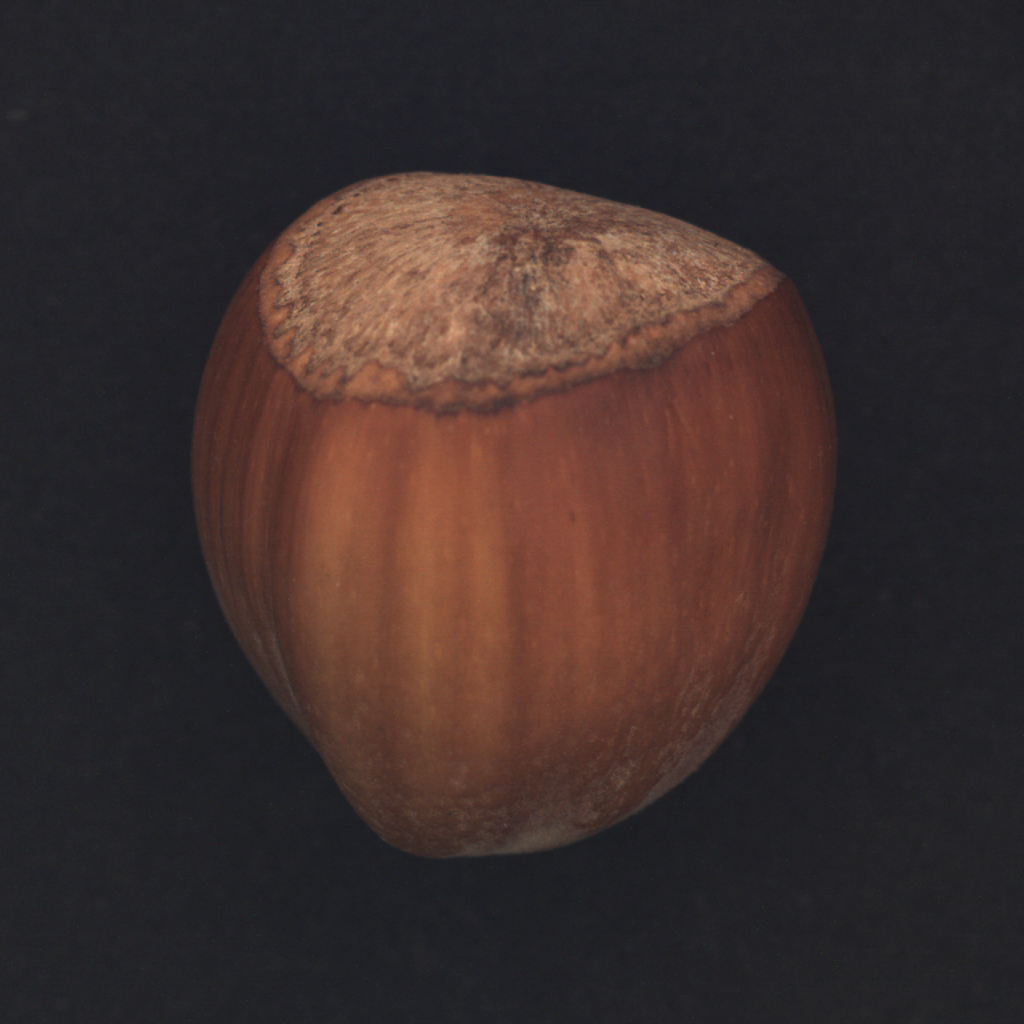Your objective is to classify an image based on its corresponding object category. The image provided encompasses a diverse range of industrial items, including a bottle, cable, carpet, and more. Focus on the overall visual appearance of the image, paying attention to details such as lines, shading, color scheme, and level of detail. It is crucial to analyze the distinctive characteristics of the object, such as its shape, color, and texture, as these features may vary significantly between different object categories. Once you have completed the classification process, output the appropriate object name based on your analysis. Upon analyzing the image, the object can be classified in the 'food' category, more specifically as a 'nut.' This classification is based on the distinctive characteristics of the object, which include its smooth, rounded shape and the textured cap typical of hazelnuts. The color scheme consists of a gradient of browns, common to the natural shell of a hazelnut. The texture is smooth with a matte finish on the body, while the cap has a rough, fibrous edge, which is a natural trait of the hazelnut's husk. Considering these details, the appropriate object name based on the analysis is "hazelnut." 